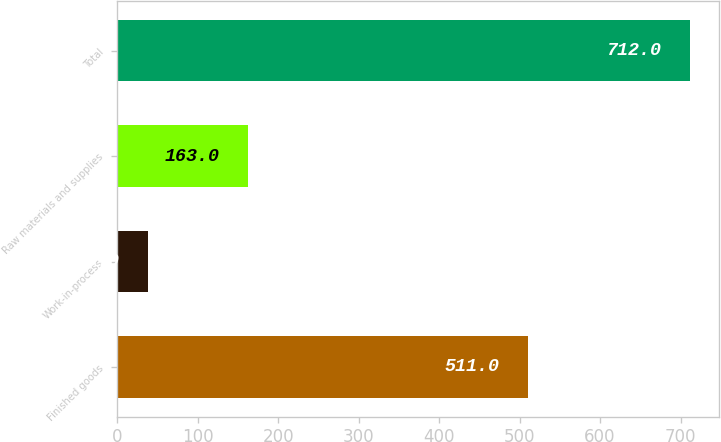Convert chart to OTSL. <chart><loc_0><loc_0><loc_500><loc_500><bar_chart><fcel>Finished goods<fcel>Work-in-process<fcel>Raw materials and supplies<fcel>Total<nl><fcel>511<fcel>38<fcel>163<fcel>712<nl></chart> 